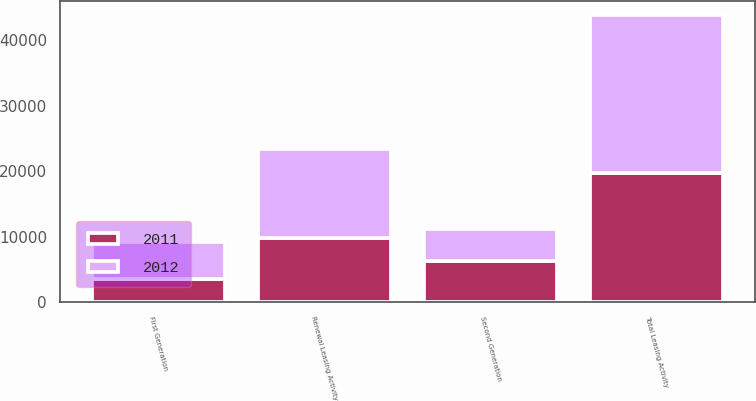<chart> <loc_0><loc_0><loc_500><loc_500><stacked_bar_chart><ecel><fcel>First Generation<fcel>Second Generation<fcel>Renewal Leasing Activity<fcel>Total Leasing Activity<nl><fcel>2012<fcel>5628<fcel>4911<fcel>13626<fcel>24165<nl><fcel>2011<fcel>3597<fcel>6256<fcel>9819<fcel>19672<nl></chart> 